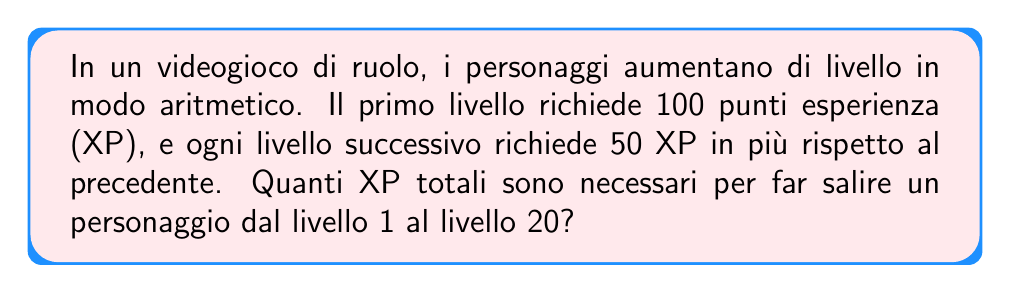Provide a solution to this math problem. Per risolvere questo problema, utilizziamo la formula della somma di una progressione aritmetica:

$$S_n = \frac{n}{2}(a_1 + a_n)$$

Dove:
$S_n$ è la somma della sequenza
$n$ è il numero di termini
$a_1$ è il primo termine
$a_n$ è l'ultimo termine

1) Determiniamo $n$:
   Dal livello 1 al 20 ci sono 20 livelli, quindi $n = 20$

2) Troviamo $a_1$:
   $a_1 = 100$ XP (per il primo livello)

3) Calcoliamo $a_n$ (XP per il 20° livello):
   $a_n = a_1 + (n-1)d$, dove $d$ è la differenza comune (50 XP)
   $a_{20} = 100 + (20-1) \cdot 50 = 100 + 950 = 1050$ XP

4) Applichiamo la formula:
   $$S_{20} = \frac{20}{2}(100 + 1050) = 10 \cdot 1150 = 11500$$

Quindi, la somma totale di XP necessari è 11500.
Answer: 11500 XP 